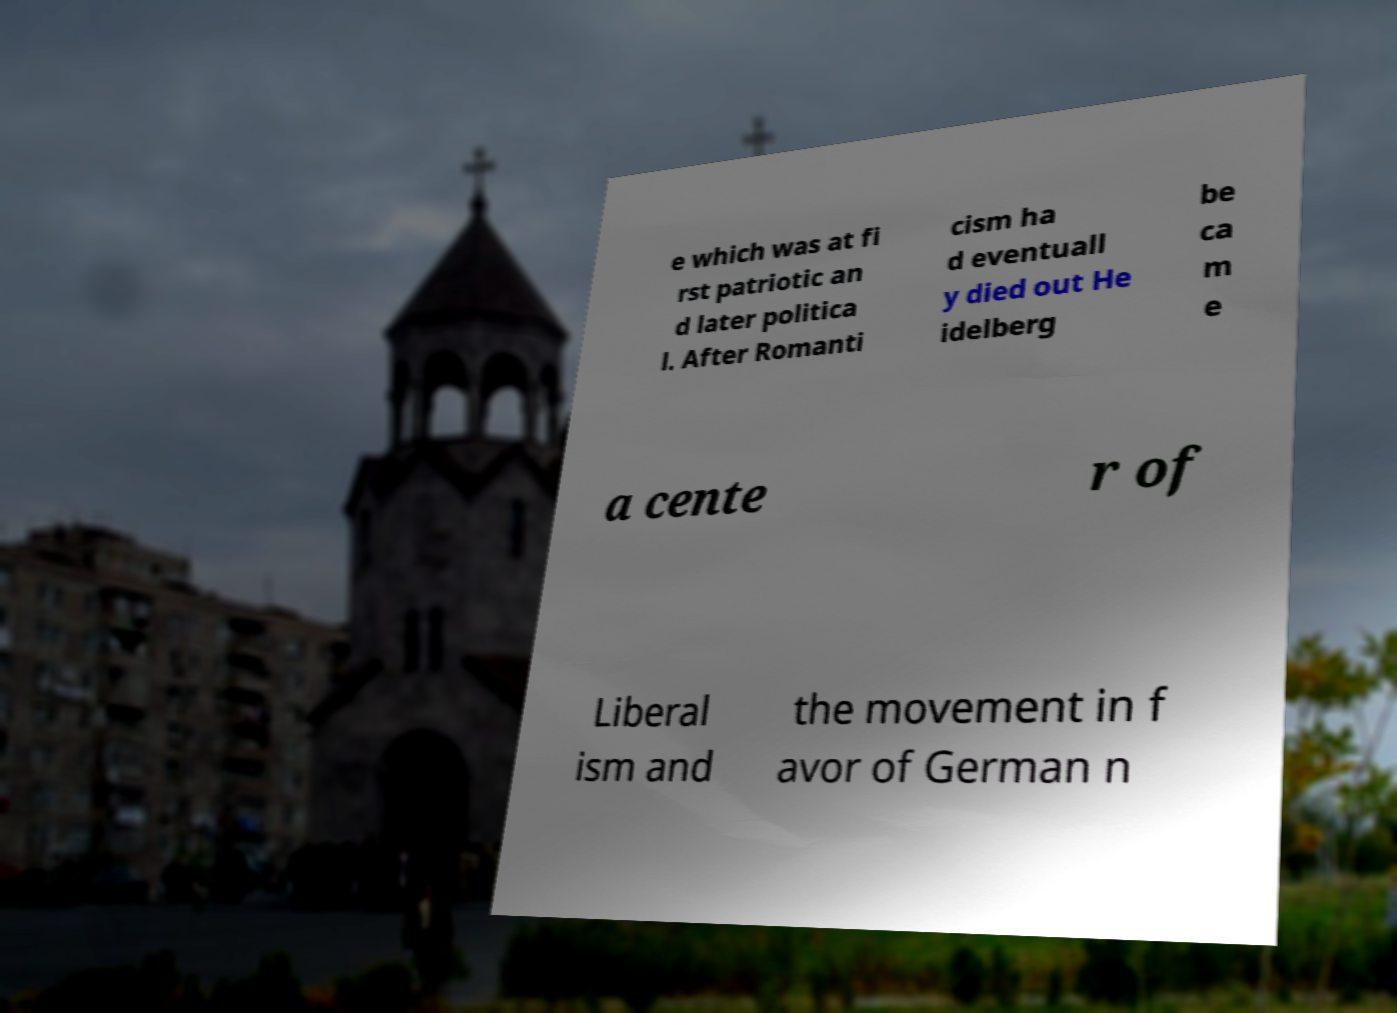Can you accurately transcribe the text from the provided image for me? e which was at fi rst patriotic an d later politica l. After Romanti cism ha d eventuall y died out He idelberg be ca m e a cente r of Liberal ism and the movement in f avor of German n 